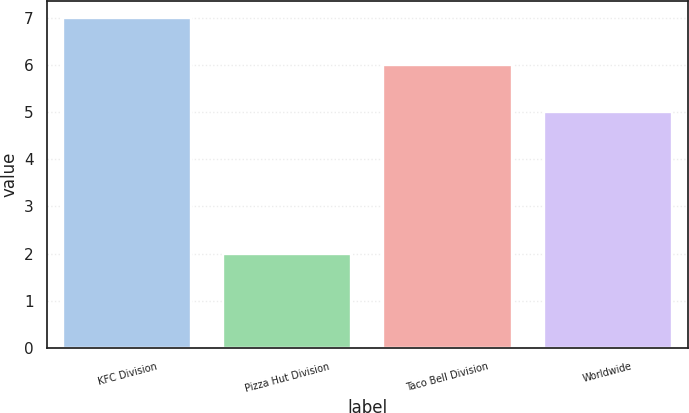Convert chart to OTSL. <chart><loc_0><loc_0><loc_500><loc_500><bar_chart><fcel>KFC Division<fcel>Pizza Hut Division<fcel>Taco Bell Division<fcel>Worldwide<nl><fcel>7<fcel>2<fcel>6<fcel>5<nl></chart> 